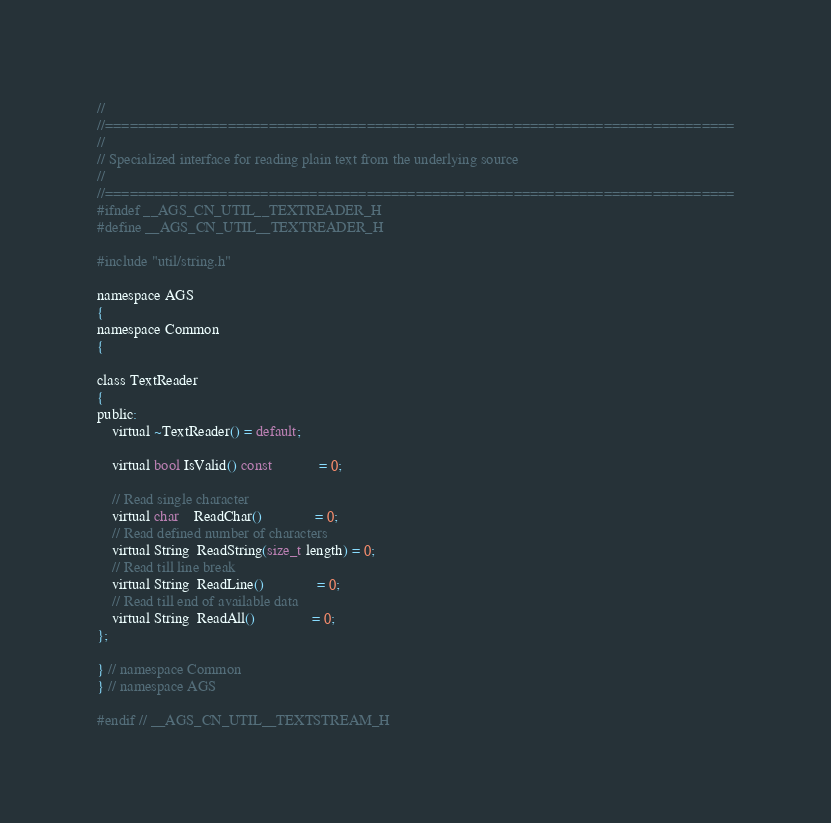Convert code to text. <code><loc_0><loc_0><loc_500><loc_500><_C_>//
//=============================================================================
//
// Specialized interface for reading plain text from the underlying source
//
//=============================================================================
#ifndef __AGS_CN_UTIL__TEXTREADER_H
#define __AGS_CN_UTIL__TEXTREADER_H

#include "util/string.h"

namespace AGS
{
namespace Common
{

class TextReader
{
public:
    virtual ~TextReader() = default;

    virtual bool IsValid() const            = 0;

    // Read single character
    virtual char    ReadChar()              = 0;
    // Read defined number of characters
    virtual String  ReadString(size_t length) = 0;
    // Read till line break
    virtual String  ReadLine()              = 0;
    // Read till end of available data
    virtual String  ReadAll()               = 0;
};

} // namespace Common
} // namespace AGS

#endif // __AGS_CN_UTIL__TEXTSTREAM_H
</code> 